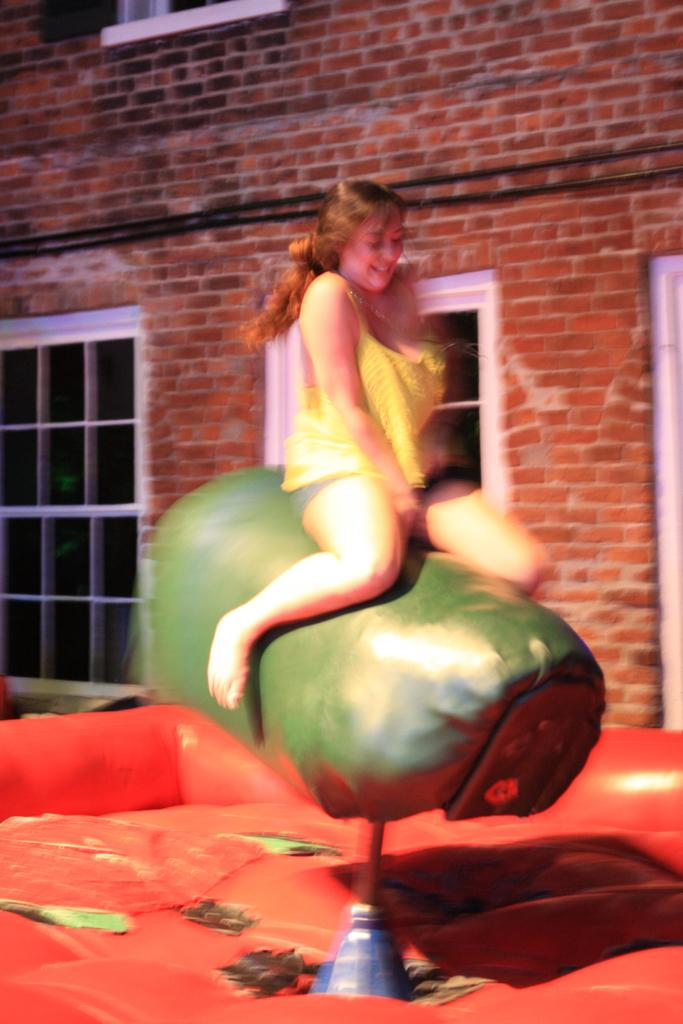Who is the main subject in the image? There is a woman in the image. What is the woman sitting on? The woman is sitting on a green object that resembles a trampoline. What can be seen in the background of the image? There is a wall and windows in the background of the image. What type of letters can be seen being written on the trampoline in the image? There are no letters or writing present on the trampoline in the image. What kind of sound can be heard coming from the woman in the image? There is no sound or audio information provided in the image, so it cannot be determined what sound might be heard. 